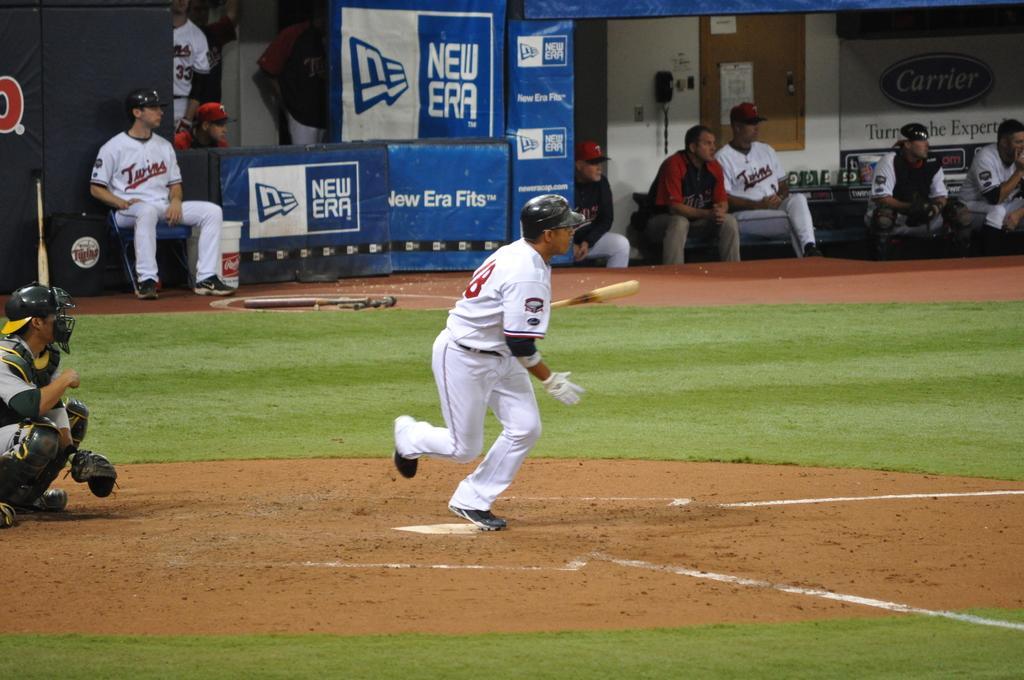Please provide a concise description of this image. In this picture we can see people playing baseball on the ground. In the background, we can see other people sitting on the chairs. 